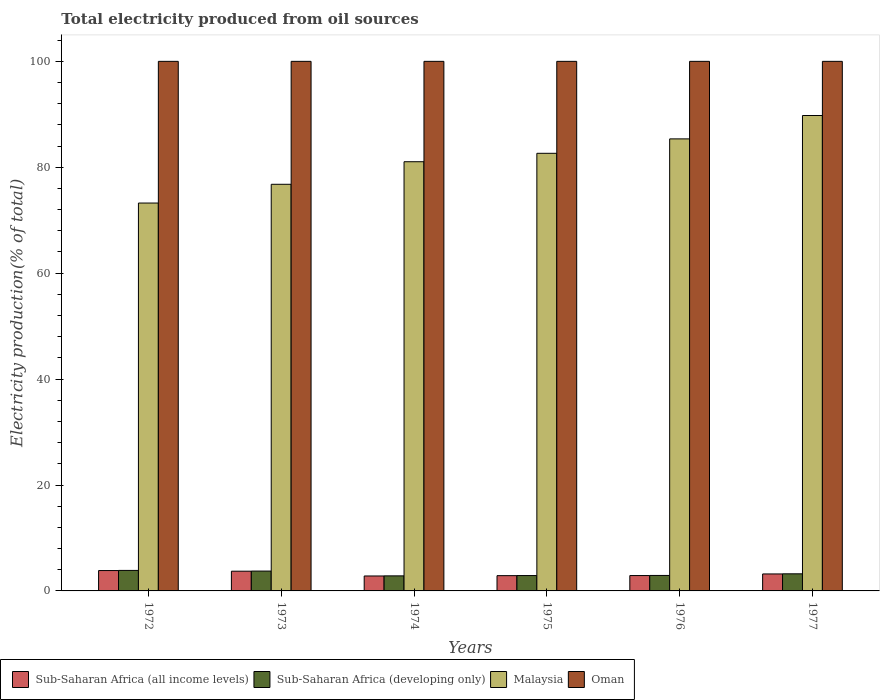How many different coloured bars are there?
Your answer should be compact. 4. Are the number of bars on each tick of the X-axis equal?
Offer a terse response. Yes. How many bars are there on the 5th tick from the left?
Make the answer very short. 4. What is the label of the 5th group of bars from the left?
Your answer should be compact. 1976. In how many cases, is the number of bars for a given year not equal to the number of legend labels?
Your answer should be compact. 0. What is the total electricity produced in Sub-Saharan Africa (all income levels) in 1972?
Offer a terse response. 3.84. Across all years, what is the maximum total electricity produced in Malaysia?
Provide a short and direct response. 89.77. Across all years, what is the minimum total electricity produced in Sub-Saharan Africa (all income levels)?
Your response must be concise. 2.82. What is the total total electricity produced in Sub-Saharan Africa (developing only) in the graph?
Offer a very short reply. 19.52. What is the difference between the total electricity produced in Sub-Saharan Africa (all income levels) in 1974 and that in 1976?
Offer a very short reply. -0.08. What is the difference between the total electricity produced in Sub-Saharan Africa (developing only) in 1977 and the total electricity produced in Malaysia in 1974?
Your answer should be compact. -77.82. What is the average total electricity produced in Malaysia per year?
Your answer should be compact. 81.47. In the year 1975, what is the difference between the total electricity produced in Malaysia and total electricity produced in Sub-Saharan Africa (all income levels)?
Provide a succinct answer. 79.75. In how many years, is the total electricity produced in Malaysia greater than 44 %?
Offer a terse response. 6. What is the ratio of the total electricity produced in Malaysia in 1974 to that in 1977?
Keep it short and to the point. 0.9. Is the difference between the total electricity produced in Malaysia in 1975 and 1976 greater than the difference between the total electricity produced in Sub-Saharan Africa (all income levels) in 1975 and 1976?
Your response must be concise. No. What is the difference between the highest and the second highest total electricity produced in Malaysia?
Your answer should be very brief. 4.41. What is the difference between the highest and the lowest total electricity produced in Malaysia?
Your answer should be compact. 16.53. What does the 3rd bar from the left in 1974 represents?
Offer a terse response. Malaysia. What does the 2nd bar from the right in 1972 represents?
Your answer should be very brief. Malaysia. Does the graph contain any zero values?
Offer a very short reply. No. Does the graph contain grids?
Your response must be concise. No. How are the legend labels stacked?
Keep it short and to the point. Horizontal. What is the title of the graph?
Your response must be concise. Total electricity produced from oil sources. Does "Somalia" appear as one of the legend labels in the graph?
Your answer should be compact. No. What is the label or title of the X-axis?
Your answer should be very brief. Years. What is the Electricity production(% of total) in Sub-Saharan Africa (all income levels) in 1972?
Your response must be concise. 3.84. What is the Electricity production(% of total) of Sub-Saharan Africa (developing only) in 1972?
Your response must be concise. 3.87. What is the Electricity production(% of total) in Malaysia in 1972?
Offer a terse response. 73.24. What is the Electricity production(% of total) of Oman in 1972?
Offer a terse response. 100. What is the Electricity production(% of total) in Sub-Saharan Africa (all income levels) in 1973?
Provide a short and direct response. 3.72. What is the Electricity production(% of total) of Sub-Saharan Africa (developing only) in 1973?
Offer a very short reply. 3.75. What is the Electricity production(% of total) in Malaysia in 1973?
Keep it short and to the point. 76.79. What is the Electricity production(% of total) of Sub-Saharan Africa (all income levels) in 1974?
Make the answer very short. 2.82. What is the Electricity production(% of total) in Sub-Saharan Africa (developing only) in 1974?
Offer a terse response. 2.84. What is the Electricity production(% of total) in Malaysia in 1974?
Offer a very short reply. 81.05. What is the Electricity production(% of total) in Oman in 1974?
Your answer should be compact. 100. What is the Electricity production(% of total) in Sub-Saharan Africa (all income levels) in 1975?
Provide a succinct answer. 2.88. What is the Electricity production(% of total) in Sub-Saharan Africa (developing only) in 1975?
Your answer should be very brief. 2.9. What is the Electricity production(% of total) in Malaysia in 1975?
Make the answer very short. 82.64. What is the Electricity production(% of total) of Oman in 1975?
Ensure brevity in your answer.  100. What is the Electricity production(% of total) in Sub-Saharan Africa (all income levels) in 1976?
Your response must be concise. 2.9. What is the Electricity production(% of total) in Sub-Saharan Africa (developing only) in 1976?
Make the answer very short. 2.92. What is the Electricity production(% of total) in Malaysia in 1976?
Give a very brief answer. 85.36. What is the Electricity production(% of total) of Oman in 1976?
Provide a short and direct response. 100. What is the Electricity production(% of total) in Sub-Saharan Africa (all income levels) in 1977?
Offer a very short reply. 3.21. What is the Electricity production(% of total) of Sub-Saharan Africa (developing only) in 1977?
Make the answer very short. 3.23. What is the Electricity production(% of total) of Malaysia in 1977?
Your answer should be compact. 89.77. What is the Electricity production(% of total) of Oman in 1977?
Offer a terse response. 100. Across all years, what is the maximum Electricity production(% of total) in Sub-Saharan Africa (all income levels)?
Provide a succinct answer. 3.84. Across all years, what is the maximum Electricity production(% of total) in Sub-Saharan Africa (developing only)?
Provide a short and direct response. 3.87. Across all years, what is the maximum Electricity production(% of total) in Malaysia?
Provide a short and direct response. 89.77. Across all years, what is the maximum Electricity production(% of total) in Oman?
Offer a terse response. 100. Across all years, what is the minimum Electricity production(% of total) in Sub-Saharan Africa (all income levels)?
Provide a short and direct response. 2.82. Across all years, what is the minimum Electricity production(% of total) of Sub-Saharan Africa (developing only)?
Keep it short and to the point. 2.84. Across all years, what is the minimum Electricity production(% of total) of Malaysia?
Your answer should be very brief. 73.24. What is the total Electricity production(% of total) of Sub-Saharan Africa (all income levels) in the graph?
Your answer should be very brief. 19.38. What is the total Electricity production(% of total) in Sub-Saharan Africa (developing only) in the graph?
Offer a terse response. 19.52. What is the total Electricity production(% of total) in Malaysia in the graph?
Your answer should be very brief. 488.85. What is the total Electricity production(% of total) of Oman in the graph?
Your answer should be compact. 600. What is the difference between the Electricity production(% of total) of Sub-Saharan Africa (all income levels) in 1972 and that in 1973?
Offer a very short reply. 0.12. What is the difference between the Electricity production(% of total) of Sub-Saharan Africa (developing only) in 1972 and that in 1973?
Provide a short and direct response. 0.12. What is the difference between the Electricity production(% of total) in Malaysia in 1972 and that in 1973?
Provide a succinct answer. -3.54. What is the difference between the Electricity production(% of total) of Sub-Saharan Africa (all income levels) in 1972 and that in 1974?
Provide a succinct answer. 1.02. What is the difference between the Electricity production(% of total) in Sub-Saharan Africa (developing only) in 1972 and that in 1974?
Provide a short and direct response. 1.03. What is the difference between the Electricity production(% of total) in Malaysia in 1972 and that in 1974?
Give a very brief answer. -7.8. What is the difference between the Electricity production(% of total) in Oman in 1972 and that in 1974?
Keep it short and to the point. 0. What is the difference between the Electricity production(% of total) in Sub-Saharan Africa (all income levels) in 1972 and that in 1975?
Your answer should be very brief. 0.96. What is the difference between the Electricity production(% of total) in Sub-Saharan Africa (developing only) in 1972 and that in 1975?
Provide a succinct answer. 0.97. What is the difference between the Electricity production(% of total) of Malaysia in 1972 and that in 1975?
Offer a terse response. -9.39. What is the difference between the Electricity production(% of total) in Oman in 1972 and that in 1975?
Provide a succinct answer. 0. What is the difference between the Electricity production(% of total) in Sub-Saharan Africa (all income levels) in 1972 and that in 1976?
Provide a short and direct response. 0.94. What is the difference between the Electricity production(% of total) of Sub-Saharan Africa (developing only) in 1972 and that in 1976?
Your response must be concise. 0.95. What is the difference between the Electricity production(% of total) in Malaysia in 1972 and that in 1976?
Make the answer very short. -12.12. What is the difference between the Electricity production(% of total) in Oman in 1972 and that in 1976?
Offer a terse response. 0. What is the difference between the Electricity production(% of total) of Sub-Saharan Africa (all income levels) in 1972 and that in 1977?
Your answer should be compact. 0.64. What is the difference between the Electricity production(% of total) in Sub-Saharan Africa (developing only) in 1972 and that in 1977?
Your response must be concise. 0.64. What is the difference between the Electricity production(% of total) in Malaysia in 1972 and that in 1977?
Your answer should be compact. -16.53. What is the difference between the Electricity production(% of total) in Oman in 1972 and that in 1977?
Your response must be concise. 0. What is the difference between the Electricity production(% of total) in Sub-Saharan Africa (all income levels) in 1973 and that in 1974?
Make the answer very short. 0.9. What is the difference between the Electricity production(% of total) in Sub-Saharan Africa (developing only) in 1973 and that in 1974?
Ensure brevity in your answer.  0.91. What is the difference between the Electricity production(% of total) in Malaysia in 1973 and that in 1974?
Your response must be concise. -4.26. What is the difference between the Electricity production(% of total) of Oman in 1973 and that in 1974?
Provide a short and direct response. 0. What is the difference between the Electricity production(% of total) in Sub-Saharan Africa (all income levels) in 1973 and that in 1975?
Your answer should be very brief. 0.84. What is the difference between the Electricity production(% of total) in Sub-Saharan Africa (developing only) in 1973 and that in 1975?
Keep it short and to the point. 0.85. What is the difference between the Electricity production(% of total) of Malaysia in 1973 and that in 1975?
Your response must be concise. -5.85. What is the difference between the Electricity production(% of total) of Sub-Saharan Africa (all income levels) in 1973 and that in 1976?
Offer a very short reply. 0.82. What is the difference between the Electricity production(% of total) in Sub-Saharan Africa (developing only) in 1973 and that in 1976?
Offer a very short reply. 0.83. What is the difference between the Electricity production(% of total) in Malaysia in 1973 and that in 1976?
Keep it short and to the point. -8.58. What is the difference between the Electricity production(% of total) in Oman in 1973 and that in 1976?
Your answer should be very brief. 0. What is the difference between the Electricity production(% of total) in Sub-Saharan Africa (all income levels) in 1973 and that in 1977?
Ensure brevity in your answer.  0.52. What is the difference between the Electricity production(% of total) of Sub-Saharan Africa (developing only) in 1973 and that in 1977?
Your response must be concise. 0.52. What is the difference between the Electricity production(% of total) in Malaysia in 1973 and that in 1977?
Provide a succinct answer. -12.99. What is the difference between the Electricity production(% of total) of Oman in 1973 and that in 1977?
Provide a short and direct response. 0. What is the difference between the Electricity production(% of total) in Sub-Saharan Africa (all income levels) in 1974 and that in 1975?
Make the answer very short. -0.06. What is the difference between the Electricity production(% of total) of Sub-Saharan Africa (developing only) in 1974 and that in 1975?
Keep it short and to the point. -0.06. What is the difference between the Electricity production(% of total) in Malaysia in 1974 and that in 1975?
Keep it short and to the point. -1.59. What is the difference between the Electricity production(% of total) in Oman in 1974 and that in 1975?
Keep it short and to the point. 0. What is the difference between the Electricity production(% of total) of Sub-Saharan Africa (all income levels) in 1974 and that in 1976?
Offer a very short reply. -0.08. What is the difference between the Electricity production(% of total) in Sub-Saharan Africa (developing only) in 1974 and that in 1976?
Offer a very short reply. -0.08. What is the difference between the Electricity production(% of total) of Malaysia in 1974 and that in 1976?
Make the answer very short. -4.31. What is the difference between the Electricity production(% of total) of Sub-Saharan Africa (all income levels) in 1974 and that in 1977?
Your answer should be very brief. -0.39. What is the difference between the Electricity production(% of total) of Sub-Saharan Africa (developing only) in 1974 and that in 1977?
Provide a short and direct response. -0.39. What is the difference between the Electricity production(% of total) in Malaysia in 1974 and that in 1977?
Your response must be concise. -8.73. What is the difference between the Electricity production(% of total) in Oman in 1974 and that in 1977?
Ensure brevity in your answer.  0. What is the difference between the Electricity production(% of total) in Sub-Saharan Africa (all income levels) in 1975 and that in 1976?
Ensure brevity in your answer.  -0.02. What is the difference between the Electricity production(% of total) in Sub-Saharan Africa (developing only) in 1975 and that in 1976?
Provide a succinct answer. -0.02. What is the difference between the Electricity production(% of total) of Malaysia in 1975 and that in 1976?
Your answer should be very brief. -2.72. What is the difference between the Electricity production(% of total) in Sub-Saharan Africa (all income levels) in 1975 and that in 1977?
Provide a short and direct response. -0.32. What is the difference between the Electricity production(% of total) of Sub-Saharan Africa (developing only) in 1975 and that in 1977?
Your answer should be very brief. -0.33. What is the difference between the Electricity production(% of total) in Malaysia in 1975 and that in 1977?
Ensure brevity in your answer.  -7.14. What is the difference between the Electricity production(% of total) of Sub-Saharan Africa (all income levels) in 1976 and that in 1977?
Your answer should be compact. -0.3. What is the difference between the Electricity production(% of total) in Sub-Saharan Africa (developing only) in 1976 and that in 1977?
Offer a terse response. -0.31. What is the difference between the Electricity production(% of total) of Malaysia in 1976 and that in 1977?
Provide a succinct answer. -4.41. What is the difference between the Electricity production(% of total) of Sub-Saharan Africa (all income levels) in 1972 and the Electricity production(% of total) of Sub-Saharan Africa (developing only) in 1973?
Give a very brief answer. 0.1. What is the difference between the Electricity production(% of total) of Sub-Saharan Africa (all income levels) in 1972 and the Electricity production(% of total) of Malaysia in 1973?
Your answer should be very brief. -72.94. What is the difference between the Electricity production(% of total) of Sub-Saharan Africa (all income levels) in 1972 and the Electricity production(% of total) of Oman in 1973?
Ensure brevity in your answer.  -96.16. What is the difference between the Electricity production(% of total) in Sub-Saharan Africa (developing only) in 1972 and the Electricity production(% of total) in Malaysia in 1973?
Ensure brevity in your answer.  -72.91. What is the difference between the Electricity production(% of total) in Sub-Saharan Africa (developing only) in 1972 and the Electricity production(% of total) in Oman in 1973?
Your response must be concise. -96.13. What is the difference between the Electricity production(% of total) in Malaysia in 1972 and the Electricity production(% of total) in Oman in 1973?
Provide a short and direct response. -26.76. What is the difference between the Electricity production(% of total) in Sub-Saharan Africa (all income levels) in 1972 and the Electricity production(% of total) in Malaysia in 1974?
Your response must be concise. -77.2. What is the difference between the Electricity production(% of total) in Sub-Saharan Africa (all income levels) in 1972 and the Electricity production(% of total) in Oman in 1974?
Provide a short and direct response. -96.16. What is the difference between the Electricity production(% of total) of Sub-Saharan Africa (developing only) in 1972 and the Electricity production(% of total) of Malaysia in 1974?
Ensure brevity in your answer.  -77.18. What is the difference between the Electricity production(% of total) in Sub-Saharan Africa (developing only) in 1972 and the Electricity production(% of total) in Oman in 1974?
Ensure brevity in your answer.  -96.13. What is the difference between the Electricity production(% of total) in Malaysia in 1972 and the Electricity production(% of total) in Oman in 1974?
Your answer should be compact. -26.76. What is the difference between the Electricity production(% of total) in Sub-Saharan Africa (all income levels) in 1972 and the Electricity production(% of total) in Sub-Saharan Africa (developing only) in 1975?
Ensure brevity in your answer.  0.94. What is the difference between the Electricity production(% of total) in Sub-Saharan Africa (all income levels) in 1972 and the Electricity production(% of total) in Malaysia in 1975?
Offer a terse response. -78.79. What is the difference between the Electricity production(% of total) in Sub-Saharan Africa (all income levels) in 1972 and the Electricity production(% of total) in Oman in 1975?
Make the answer very short. -96.16. What is the difference between the Electricity production(% of total) in Sub-Saharan Africa (developing only) in 1972 and the Electricity production(% of total) in Malaysia in 1975?
Offer a terse response. -78.76. What is the difference between the Electricity production(% of total) in Sub-Saharan Africa (developing only) in 1972 and the Electricity production(% of total) in Oman in 1975?
Your response must be concise. -96.13. What is the difference between the Electricity production(% of total) of Malaysia in 1972 and the Electricity production(% of total) of Oman in 1975?
Offer a terse response. -26.76. What is the difference between the Electricity production(% of total) of Sub-Saharan Africa (all income levels) in 1972 and the Electricity production(% of total) of Sub-Saharan Africa (developing only) in 1976?
Give a very brief answer. 0.92. What is the difference between the Electricity production(% of total) of Sub-Saharan Africa (all income levels) in 1972 and the Electricity production(% of total) of Malaysia in 1976?
Offer a terse response. -81.52. What is the difference between the Electricity production(% of total) of Sub-Saharan Africa (all income levels) in 1972 and the Electricity production(% of total) of Oman in 1976?
Keep it short and to the point. -96.16. What is the difference between the Electricity production(% of total) of Sub-Saharan Africa (developing only) in 1972 and the Electricity production(% of total) of Malaysia in 1976?
Provide a short and direct response. -81.49. What is the difference between the Electricity production(% of total) in Sub-Saharan Africa (developing only) in 1972 and the Electricity production(% of total) in Oman in 1976?
Your answer should be very brief. -96.13. What is the difference between the Electricity production(% of total) in Malaysia in 1972 and the Electricity production(% of total) in Oman in 1976?
Your answer should be very brief. -26.76. What is the difference between the Electricity production(% of total) in Sub-Saharan Africa (all income levels) in 1972 and the Electricity production(% of total) in Sub-Saharan Africa (developing only) in 1977?
Provide a short and direct response. 0.62. What is the difference between the Electricity production(% of total) of Sub-Saharan Africa (all income levels) in 1972 and the Electricity production(% of total) of Malaysia in 1977?
Your answer should be compact. -85.93. What is the difference between the Electricity production(% of total) in Sub-Saharan Africa (all income levels) in 1972 and the Electricity production(% of total) in Oman in 1977?
Your answer should be very brief. -96.16. What is the difference between the Electricity production(% of total) in Sub-Saharan Africa (developing only) in 1972 and the Electricity production(% of total) in Malaysia in 1977?
Your answer should be compact. -85.9. What is the difference between the Electricity production(% of total) of Sub-Saharan Africa (developing only) in 1972 and the Electricity production(% of total) of Oman in 1977?
Give a very brief answer. -96.13. What is the difference between the Electricity production(% of total) in Malaysia in 1972 and the Electricity production(% of total) in Oman in 1977?
Ensure brevity in your answer.  -26.76. What is the difference between the Electricity production(% of total) of Sub-Saharan Africa (all income levels) in 1973 and the Electricity production(% of total) of Sub-Saharan Africa (developing only) in 1974?
Offer a very short reply. 0.88. What is the difference between the Electricity production(% of total) in Sub-Saharan Africa (all income levels) in 1973 and the Electricity production(% of total) in Malaysia in 1974?
Provide a succinct answer. -77.32. What is the difference between the Electricity production(% of total) of Sub-Saharan Africa (all income levels) in 1973 and the Electricity production(% of total) of Oman in 1974?
Your answer should be compact. -96.28. What is the difference between the Electricity production(% of total) of Sub-Saharan Africa (developing only) in 1973 and the Electricity production(% of total) of Malaysia in 1974?
Ensure brevity in your answer.  -77.3. What is the difference between the Electricity production(% of total) in Sub-Saharan Africa (developing only) in 1973 and the Electricity production(% of total) in Oman in 1974?
Provide a succinct answer. -96.25. What is the difference between the Electricity production(% of total) of Malaysia in 1973 and the Electricity production(% of total) of Oman in 1974?
Keep it short and to the point. -23.21. What is the difference between the Electricity production(% of total) in Sub-Saharan Africa (all income levels) in 1973 and the Electricity production(% of total) in Sub-Saharan Africa (developing only) in 1975?
Offer a terse response. 0.82. What is the difference between the Electricity production(% of total) in Sub-Saharan Africa (all income levels) in 1973 and the Electricity production(% of total) in Malaysia in 1975?
Offer a terse response. -78.91. What is the difference between the Electricity production(% of total) in Sub-Saharan Africa (all income levels) in 1973 and the Electricity production(% of total) in Oman in 1975?
Provide a succinct answer. -96.28. What is the difference between the Electricity production(% of total) of Sub-Saharan Africa (developing only) in 1973 and the Electricity production(% of total) of Malaysia in 1975?
Ensure brevity in your answer.  -78.89. What is the difference between the Electricity production(% of total) of Sub-Saharan Africa (developing only) in 1973 and the Electricity production(% of total) of Oman in 1975?
Offer a very short reply. -96.25. What is the difference between the Electricity production(% of total) of Malaysia in 1973 and the Electricity production(% of total) of Oman in 1975?
Offer a terse response. -23.21. What is the difference between the Electricity production(% of total) in Sub-Saharan Africa (all income levels) in 1973 and the Electricity production(% of total) in Sub-Saharan Africa (developing only) in 1976?
Provide a succinct answer. 0.8. What is the difference between the Electricity production(% of total) of Sub-Saharan Africa (all income levels) in 1973 and the Electricity production(% of total) of Malaysia in 1976?
Provide a short and direct response. -81.64. What is the difference between the Electricity production(% of total) of Sub-Saharan Africa (all income levels) in 1973 and the Electricity production(% of total) of Oman in 1976?
Provide a succinct answer. -96.28. What is the difference between the Electricity production(% of total) of Sub-Saharan Africa (developing only) in 1973 and the Electricity production(% of total) of Malaysia in 1976?
Make the answer very short. -81.61. What is the difference between the Electricity production(% of total) of Sub-Saharan Africa (developing only) in 1973 and the Electricity production(% of total) of Oman in 1976?
Ensure brevity in your answer.  -96.25. What is the difference between the Electricity production(% of total) in Malaysia in 1973 and the Electricity production(% of total) in Oman in 1976?
Keep it short and to the point. -23.21. What is the difference between the Electricity production(% of total) in Sub-Saharan Africa (all income levels) in 1973 and the Electricity production(% of total) in Sub-Saharan Africa (developing only) in 1977?
Offer a very short reply. 0.49. What is the difference between the Electricity production(% of total) in Sub-Saharan Africa (all income levels) in 1973 and the Electricity production(% of total) in Malaysia in 1977?
Your answer should be compact. -86.05. What is the difference between the Electricity production(% of total) of Sub-Saharan Africa (all income levels) in 1973 and the Electricity production(% of total) of Oman in 1977?
Keep it short and to the point. -96.28. What is the difference between the Electricity production(% of total) of Sub-Saharan Africa (developing only) in 1973 and the Electricity production(% of total) of Malaysia in 1977?
Make the answer very short. -86.02. What is the difference between the Electricity production(% of total) in Sub-Saharan Africa (developing only) in 1973 and the Electricity production(% of total) in Oman in 1977?
Your response must be concise. -96.25. What is the difference between the Electricity production(% of total) in Malaysia in 1973 and the Electricity production(% of total) in Oman in 1977?
Your response must be concise. -23.21. What is the difference between the Electricity production(% of total) in Sub-Saharan Africa (all income levels) in 1974 and the Electricity production(% of total) in Sub-Saharan Africa (developing only) in 1975?
Your response must be concise. -0.08. What is the difference between the Electricity production(% of total) in Sub-Saharan Africa (all income levels) in 1974 and the Electricity production(% of total) in Malaysia in 1975?
Offer a very short reply. -79.81. What is the difference between the Electricity production(% of total) of Sub-Saharan Africa (all income levels) in 1974 and the Electricity production(% of total) of Oman in 1975?
Your response must be concise. -97.18. What is the difference between the Electricity production(% of total) of Sub-Saharan Africa (developing only) in 1974 and the Electricity production(% of total) of Malaysia in 1975?
Provide a short and direct response. -79.8. What is the difference between the Electricity production(% of total) in Sub-Saharan Africa (developing only) in 1974 and the Electricity production(% of total) in Oman in 1975?
Provide a succinct answer. -97.16. What is the difference between the Electricity production(% of total) of Malaysia in 1974 and the Electricity production(% of total) of Oman in 1975?
Your answer should be very brief. -18.95. What is the difference between the Electricity production(% of total) in Sub-Saharan Africa (all income levels) in 1974 and the Electricity production(% of total) in Sub-Saharan Africa (developing only) in 1976?
Make the answer very short. -0.1. What is the difference between the Electricity production(% of total) in Sub-Saharan Africa (all income levels) in 1974 and the Electricity production(% of total) in Malaysia in 1976?
Your answer should be compact. -82.54. What is the difference between the Electricity production(% of total) of Sub-Saharan Africa (all income levels) in 1974 and the Electricity production(% of total) of Oman in 1976?
Make the answer very short. -97.18. What is the difference between the Electricity production(% of total) of Sub-Saharan Africa (developing only) in 1974 and the Electricity production(% of total) of Malaysia in 1976?
Your response must be concise. -82.52. What is the difference between the Electricity production(% of total) in Sub-Saharan Africa (developing only) in 1974 and the Electricity production(% of total) in Oman in 1976?
Make the answer very short. -97.16. What is the difference between the Electricity production(% of total) of Malaysia in 1974 and the Electricity production(% of total) of Oman in 1976?
Keep it short and to the point. -18.95. What is the difference between the Electricity production(% of total) in Sub-Saharan Africa (all income levels) in 1974 and the Electricity production(% of total) in Sub-Saharan Africa (developing only) in 1977?
Provide a short and direct response. -0.41. What is the difference between the Electricity production(% of total) in Sub-Saharan Africa (all income levels) in 1974 and the Electricity production(% of total) in Malaysia in 1977?
Ensure brevity in your answer.  -86.95. What is the difference between the Electricity production(% of total) of Sub-Saharan Africa (all income levels) in 1974 and the Electricity production(% of total) of Oman in 1977?
Give a very brief answer. -97.18. What is the difference between the Electricity production(% of total) in Sub-Saharan Africa (developing only) in 1974 and the Electricity production(% of total) in Malaysia in 1977?
Your answer should be compact. -86.93. What is the difference between the Electricity production(% of total) in Sub-Saharan Africa (developing only) in 1974 and the Electricity production(% of total) in Oman in 1977?
Provide a short and direct response. -97.16. What is the difference between the Electricity production(% of total) of Malaysia in 1974 and the Electricity production(% of total) of Oman in 1977?
Your response must be concise. -18.95. What is the difference between the Electricity production(% of total) of Sub-Saharan Africa (all income levels) in 1975 and the Electricity production(% of total) of Sub-Saharan Africa (developing only) in 1976?
Offer a terse response. -0.04. What is the difference between the Electricity production(% of total) in Sub-Saharan Africa (all income levels) in 1975 and the Electricity production(% of total) in Malaysia in 1976?
Your response must be concise. -82.48. What is the difference between the Electricity production(% of total) in Sub-Saharan Africa (all income levels) in 1975 and the Electricity production(% of total) in Oman in 1976?
Offer a very short reply. -97.12. What is the difference between the Electricity production(% of total) of Sub-Saharan Africa (developing only) in 1975 and the Electricity production(% of total) of Malaysia in 1976?
Give a very brief answer. -82.46. What is the difference between the Electricity production(% of total) of Sub-Saharan Africa (developing only) in 1975 and the Electricity production(% of total) of Oman in 1976?
Your response must be concise. -97.1. What is the difference between the Electricity production(% of total) in Malaysia in 1975 and the Electricity production(% of total) in Oman in 1976?
Ensure brevity in your answer.  -17.36. What is the difference between the Electricity production(% of total) in Sub-Saharan Africa (all income levels) in 1975 and the Electricity production(% of total) in Sub-Saharan Africa (developing only) in 1977?
Give a very brief answer. -0.35. What is the difference between the Electricity production(% of total) in Sub-Saharan Africa (all income levels) in 1975 and the Electricity production(% of total) in Malaysia in 1977?
Give a very brief answer. -86.89. What is the difference between the Electricity production(% of total) of Sub-Saharan Africa (all income levels) in 1975 and the Electricity production(% of total) of Oman in 1977?
Provide a short and direct response. -97.12. What is the difference between the Electricity production(% of total) of Sub-Saharan Africa (developing only) in 1975 and the Electricity production(% of total) of Malaysia in 1977?
Provide a succinct answer. -86.87. What is the difference between the Electricity production(% of total) of Sub-Saharan Africa (developing only) in 1975 and the Electricity production(% of total) of Oman in 1977?
Offer a very short reply. -97.1. What is the difference between the Electricity production(% of total) in Malaysia in 1975 and the Electricity production(% of total) in Oman in 1977?
Your answer should be compact. -17.36. What is the difference between the Electricity production(% of total) of Sub-Saharan Africa (all income levels) in 1976 and the Electricity production(% of total) of Sub-Saharan Africa (developing only) in 1977?
Give a very brief answer. -0.33. What is the difference between the Electricity production(% of total) of Sub-Saharan Africa (all income levels) in 1976 and the Electricity production(% of total) of Malaysia in 1977?
Your answer should be compact. -86.87. What is the difference between the Electricity production(% of total) of Sub-Saharan Africa (all income levels) in 1976 and the Electricity production(% of total) of Oman in 1977?
Provide a succinct answer. -97.1. What is the difference between the Electricity production(% of total) of Sub-Saharan Africa (developing only) in 1976 and the Electricity production(% of total) of Malaysia in 1977?
Offer a very short reply. -86.85. What is the difference between the Electricity production(% of total) of Sub-Saharan Africa (developing only) in 1976 and the Electricity production(% of total) of Oman in 1977?
Offer a terse response. -97.08. What is the difference between the Electricity production(% of total) in Malaysia in 1976 and the Electricity production(% of total) in Oman in 1977?
Keep it short and to the point. -14.64. What is the average Electricity production(% of total) in Sub-Saharan Africa (all income levels) per year?
Your answer should be compact. 3.23. What is the average Electricity production(% of total) of Sub-Saharan Africa (developing only) per year?
Your answer should be compact. 3.25. What is the average Electricity production(% of total) of Malaysia per year?
Your answer should be very brief. 81.47. In the year 1972, what is the difference between the Electricity production(% of total) of Sub-Saharan Africa (all income levels) and Electricity production(% of total) of Sub-Saharan Africa (developing only)?
Provide a succinct answer. -0.03. In the year 1972, what is the difference between the Electricity production(% of total) of Sub-Saharan Africa (all income levels) and Electricity production(% of total) of Malaysia?
Your response must be concise. -69.4. In the year 1972, what is the difference between the Electricity production(% of total) of Sub-Saharan Africa (all income levels) and Electricity production(% of total) of Oman?
Your answer should be very brief. -96.16. In the year 1972, what is the difference between the Electricity production(% of total) of Sub-Saharan Africa (developing only) and Electricity production(% of total) of Malaysia?
Give a very brief answer. -69.37. In the year 1972, what is the difference between the Electricity production(% of total) in Sub-Saharan Africa (developing only) and Electricity production(% of total) in Oman?
Keep it short and to the point. -96.13. In the year 1972, what is the difference between the Electricity production(% of total) of Malaysia and Electricity production(% of total) of Oman?
Offer a terse response. -26.76. In the year 1973, what is the difference between the Electricity production(% of total) of Sub-Saharan Africa (all income levels) and Electricity production(% of total) of Sub-Saharan Africa (developing only)?
Provide a short and direct response. -0.03. In the year 1973, what is the difference between the Electricity production(% of total) of Sub-Saharan Africa (all income levels) and Electricity production(% of total) of Malaysia?
Keep it short and to the point. -73.06. In the year 1973, what is the difference between the Electricity production(% of total) of Sub-Saharan Africa (all income levels) and Electricity production(% of total) of Oman?
Make the answer very short. -96.28. In the year 1973, what is the difference between the Electricity production(% of total) of Sub-Saharan Africa (developing only) and Electricity production(% of total) of Malaysia?
Give a very brief answer. -73.04. In the year 1973, what is the difference between the Electricity production(% of total) in Sub-Saharan Africa (developing only) and Electricity production(% of total) in Oman?
Your response must be concise. -96.25. In the year 1973, what is the difference between the Electricity production(% of total) in Malaysia and Electricity production(% of total) in Oman?
Your answer should be compact. -23.21. In the year 1974, what is the difference between the Electricity production(% of total) in Sub-Saharan Africa (all income levels) and Electricity production(% of total) in Sub-Saharan Africa (developing only)?
Make the answer very short. -0.02. In the year 1974, what is the difference between the Electricity production(% of total) of Sub-Saharan Africa (all income levels) and Electricity production(% of total) of Malaysia?
Make the answer very short. -78.23. In the year 1974, what is the difference between the Electricity production(% of total) in Sub-Saharan Africa (all income levels) and Electricity production(% of total) in Oman?
Your response must be concise. -97.18. In the year 1974, what is the difference between the Electricity production(% of total) in Sub-Saharan Africa (developing only) and Electricity production(% of total) in Malaysia?
Make the answer very short. -78.21. In the year 1974, what is the difference between the Electricity production(% of total) of Sub-Saharan Africa (developing only) and Electricity production(% of total) of Oman?
Make the answer very short. -97.16. In the year 1974, what is the difference between the Electricity production(% of total) of Malaysia and Electricity production(% of total) of Oman?
Keep it short and to the point. -18.95. In the year 1975, what is the difference between the Electricity production(% of total) in Sub-Saharan Africa (all income levels) and Electricity production(% of total) in Sub-Saharan Africa (developing only)?
Give a very brief answer. -0.02. In the year 1975, what is the difference between the Electricity production(% of total) of Sub-Saharan Africa (all income levels) and Electricity production(% of total) of Malaysia?
Your answer should be very brief. -79.75. In the year 1975, what is the difference between the Electricity production(% of total) in Sub-Saharan Africa (all income levels) and Electricity production(% of total) in Oman?
Provide a succinct answer. -97.12. In the year 1975, what is the difference between the Electricity production(% of total) of Sub-Saharan Africa (developing only) and Electricity production(% of total) of Malaysia?
Give a very brief answer. -79.73. In the year 1975, what is the difference between the Electricity production(% of total) in Sub-Saharan Africa (developing only) and Electricity production(% of total) in Oman?
Keep it short and to the point. -97.1. In the year 1975, what is the difference between the Electricity production(% of total) of Malaysia and Electricity production(% of total) of Oman?
Provide a short and direct response. -17.36. In the year 1976, what is the difference between the Electricity production(% of total) in Sub-Saharan Africa (all income levels) and Electricity production(% of total) in Sub-Saharan Africa (developing only)?
Provide a succinct answer. -0.02. In the year 1976, what is the difference between the Electricity production(% of total) in Sub-Saharan Africa (all income levels) and Electricity production(% of total) in Malaysia?
Provide a short and direct response. -82.46. In the year 1976, what is the difference between the Electricity production(% of total) of Sub-Saharan Africa (all income levels) and Electricity production(% of total) of Oman?
Give a very brief answer. -97.1. In the year 1976, what is the difference between the Electricity production(% of total) of Sub-Saharan Africa (developing only) and Electricity production(% of total) of Malaysia?
Provide a succinct answer. -82.44. In the year 1976, what is the difference between the Electricity production(% of total) in Sub-Saharan Africa (developing only) and Electricity production(% of total) in Oman?
Offer a very short reply. -97.08. In the year 1976, what is the difference between the Electricity production(% of total) of Malaysia and Electricity production(% of total) of Oman?
Make the answer very short. -14.64. In the year 1977, what is the difference between the Electricity production(% of total) of Sub-Saharan Africa (all income levels) and Electricity production(% of total) of Sub-Saharan Africa (developing only)?
Provide a succinct answer. -0.02. In the year 1977, what is the difference between the Electricity production(% of total) in Sub-Saharan Africa (all income levels) and Electricity production(% of total) in Malaysia?
Your response must be concise. -86.57. In the year 1977, what is the difference between the Electricity production(% of total) in Sub-Saharan Africa (all income levels) and Electricity production(% of total) in Oman?
Your answer should be very brief. -96.79. In the year 1977, what is the difference between the Electricity production(% of total) of Sub-Saharan Africa (developing only) and Electricity production(% of total) of Malaysia?
Give a very brief answer. -86.54. In the year 1977, what is the difference between the Electricity production(% of total) of Sub-Saharan Africa (developing only) and Electricity production(% of total) of Oman?
Give a very brief answer. -96.77. In the year 1977, what is the difference between the Electricity production(% of total) in Malaysia and Electricity production(% of total) in Oman?
Keep it short and to the point. -10.23. What is the ratio of the Electricity production(% of total) in Sub-Saharan Africa (all income levels) in 1972 to that in 1973?
Give a very brief answer. 1.03. What is the ratio of the Electricity production(% of total) in Sub-Saharan Africa (developing only) in 1972 to that in 1973?
Your answer should be compact. 1.03. What is the ratio of the Electricity production(% of total) in Malaysia in 1972 to that in 1973?
Provide a succinct answer. 0.95. What is the ratio of the Electricity production(% of total) of Sub-Saharan Africa (all income levels) in 1972 to that in 1974?
Offer a very short reply. 1.36. What is the ratio of the Electricity production(% of total) of Sub-Saharan Africa (developing only) in 1972 to that in 1974?
Provide a short and direct response. 1.36. What is the ratio of the Electricity production(% of total) in Malaysia in 1972 to that in 1974?
Provide a short and direct response. 0.9. What is the ratio of the Electricity production(% of total) in Sub-Saharan Africa (all income levels) in 1972 to that in 1975?
Make the answer very short. 1.33. What is the ratio of the Electricity production(% of total) of Sub-Saharan Africa (developing only) in 1972 to that in 1975?
Make the answer very short. 1.33. What is the ratio of the Electricity production(% of total) of Malaysia in 1972 to that in 1975?
Give a very brief answer. 0.89. What is the ratio of the Electricity production(% of total) of Sub-Saharan Africa (all income levels) in 1972 to that in 1976?
Offer a terse response. 1.32. What is the ratio of the Electricity production(% of total) in Sub-Saharan Africa (developing only) in 1972 to that in 1976?
Keep it short and to the point. 1.32. What is the ratio of the Electricity production(% of total) in Malaysia in 1972 to that in 1976?
Your response must be concise. 0.86. What is the ratio of the Electricity production(% of total) in Oman in 1972 to that in 1976?
Give a very brief answer. 1. What is the ratio of the Electricity production(% of total) in Sub-Saharan Africa (all income levels) in 1972 to that in 1977?
Offer a very short reply. 1.2. What is the ratio of the Electricity production(% of total) of Sub-Saharan Africa (developing only) in 1972 to that in 1977?
Your response must be concise. 1.2. What is the ratio of the Electricity production(% of total) of Malaysia in 1972 to that in 1977?
Your response must be concise. 0.82. What is the ratio of the Electricity production(% of total) of Oman in 1972 to that in 1977?
Make the answer very short. 1. What is the ratio of the Electricity production(% of total) in Sub-Saharan Africa (all income levels) in 1973 to that in 1974?
Offer a very short reply. 1.32. What is the ratio of the Electricity production(% of total) in Sub-Saharan Africa (developing only) in 1973 to that in 1974?
Offer a very short reply. 1.32. What is the ratio of the Electricity production(% of total) of Malaysia in 1973 to that in 1974?
Offer a terse response. 0.95. What is the ratio of the Electricity production(% of total) of Sub-Saharan Africa (all income levels) in 1973 to that in 1975?
Make the answer very short. 1.29. What is the ratio of the Electricity production(% of total) of Sub-Saharan Africa (developing only) in 1973 to that in 1975?
Keep it short and to the point. 1.29. What is the ratio of the Electricity production(% of total) of Malaysia in 1973 to that in 1975?
Offer a very short reply. 0.93. What is the ratio of the Electricity production(% of total) in Sub-Saharan Africa (all income levels) in 1973 to that in 1976?
Keep it short and to the point. 1.28. What is the ratio of the Electricity production(% of total) in Sub-Saharan Africa (developing only) in 1973 to that in 1976?
Your answer should be compact. 1.28. What is the ratio of the Electricity production(% of total) in Malaysia in 1973 to that in 1976?
Offer a terse response. 0.9. What is the ratio of the Electricity production(% of total) in Oman in 1973 to that in 1976?
Your answer should be compact. 1. What is the ratio of the Electricity production(% of total) in Sub-Saharan Africa (all income levels) in 1973 to that in 1977?
Your answer should be compact. 1.16. What is the ratio of the Electricity production(% of total) in Sub-Saharan Africa (developing only) in 1973 to that in 1977?
Ensure brevity in your answer.  1.16. What is the ratio of the Electricity production(% of total) in Malaysia in 1973 to that in 1977?
Your answer should be compact. 0.86. What is the ratio of the Electricity production(% of total) of Sub-Saharan Africa (all income levels) in 1974 to that in 1975?
Offer a terse response. 0.98. What is the ratio of the Electricity production(% of total) of Sub-Saharan Africa (developing only) in 1974 to that in 1975?
Your answer should be very brief. 0.98. What is the ratio of the Electricity production(% of total) of Malaysia in 1974 to that in 1975?
Keep it short and to the point. 0.98. What is the ratio of the Electricity production(% of total) in Oman in 1974 to that in 1975?
Your answer should be very brief. 1. What is the ratio of the Electricity production(% of total) in Sub-Saharan Africa (all income levels) in 1974 to that in 1976?
Your response must be concise. 0.97. What is the ratio of the Electricity production(% of total) of Sub-Saharan Africa (developing only) in 1974 to that in 1976?
Give a very brief answer. 0.97. What is the ratio of the Electricity production(% of total) of Malaysia in 1974 to that in 1976?
Give a very brief answer. 0.95. What is the ratio of the Electricity production(% of total) of Oman in 1974 to that in 1976?
Provide a short and direct response. 1. What is the ratio of the Electricity production(% of total) in Sub-Saharan Africa (all income levels) in 1974 to that in 1977?
Your answer should be very brief. 0.88. What is the ratio of the Electricity production(% of total) in Sub-Saharan Africa (developing only) in 1974 to that in 1977?
Ensure brevity in your answer.  0.88. What is the ratio of the Electricity production(% of total) in Malaysia in 1974 to that in 1977?
Ensure brevity in your answer.  0.9. What is the ratio of the Electricity production(% of total) of Oman in 1974 to that in 1977?
Keep it short and to the point. 1. What is the ratio of the Electricity production(% of total) of Sub-Saharan Africa (developing only) in 1975 to that in 1976?
Make the answer very short. 0.99. What is the ratio of the Electricity production(% of total) of Malaysia in 1975 to that in 1976?
Your response must be concise. 0.97. What is the ratio of the Electricity production(% of total) in Sub-Saharan Africa (all income levels) in 1975 to that in 1977?
Your answer should be compact. 0.9. What is the ratio of the Electricity production(% of total) of Sub-Saharan Africa (developing only) in 1975 to that in 1977?
Your response must be concise. 0.9. What is the ratio of the Electricity production(% of total) in Malaysia in 1975 to that in 1977?
Give a very brief answer. 0.92. What is the ratio of the Electricity production(% of total) in Oman in 1975 to that in 1977?
Provide a short and direct response. 1. What is the ratio of the Electricity production(% of total) of Sub-Saharan Africa (all income levels) in 1976 to that in 1977?
Give a very brief answer. 0.91. What is the ratio of the Electricity production(% of total) in Sub-Saharan Africa (developing only) in 1976 to that in 1977?
Your answer should be compact. 0.91. What is the ratio of the Electricity production(% of total) in Malaysia in 1976 to that in 1977?
Keep it short and to the point. 0.95. What is the difference between the highest and the second highest Electricity production(% of total) in Sub-Saharan Africa (all income levels)?
Offer a terse response. 0.12. What is the difference between the highest and the second highest Electricity production(% of total) in Sub-Saharan Africa (developing only)?
Give a very brief answer. 0.12. What is the difference between the highest and the second highest Electricity production(% of total) in Malaysia?
Make the answer very short. 4.41. What is the difference between the highest and the second highest Electricity production(% of total) in Oman?
Your answer should be compact. 0. What is the difference between the highest and the lowest Electricity production(% of total) in Sub-Saharan Africa (all income levels)?
Make the answer very short. 1.02. What is the difference between the highest and the lowest Electricity production(% of total) in Sub-Saharan Africa (developing only)?
Offer a very short reply. 1.03. What is the difference between the highest and the lowest Electricity production(% of total) of Malaysia?
Provide a short and direct response. 16.53. What is the difference between the highest and the lowest Electricity production(% of total) in Oman?
Your answer should be compact. 0. 